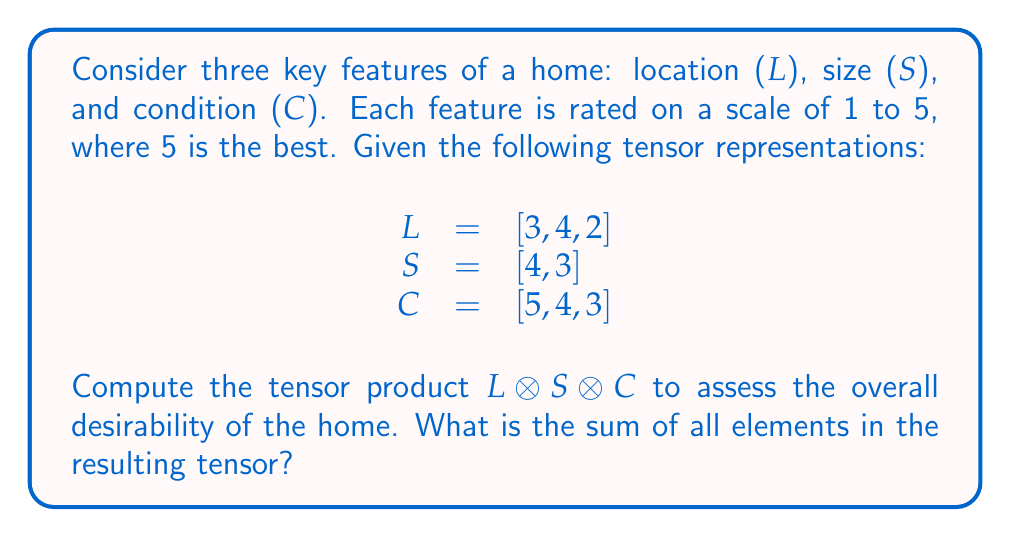What is the answer to this math problem? To solve this problem, we'll follow these steps:

1) First, let's understand what the tensor product means in this context:
   - L represents location factors (e.g., proximity to work, schools, amenities)
   - S represents size factors (e.g., square footage, number of rooms)
   - C represents condition factors (e.g., age, maintenance, updates)

2) The tensor product L ⊗ S ⊗ C will result in a 3D tensor where each element is the product of the corresponding elements from L, S, and C.

3) Let's compute the tensor product:

   $$(L \otimes S \otimes C)_{ijk} = L_i \cdot S_j \cdot C_k$$

   Where i = 1,2,3; j = 1,2; k = 1,2,3

4) Let's calculate each element:

   $$(3 \cdot 4 \cdot 5) = 60, (3 \cdot 4 \cdot 4) = 48, (3 \cdot 4 \cdot 3) = 36$$
   $$(3 \cdot 3 \cdot 5) = 45, (3 \cdot 3 \cdot 4) = 36, (3 \cdot 3 \cdot 3) = 27$$
   $$(4 \cdot 4 \cdot 5) = 80, (4 \cdot 4 \cdot 4) = 64, (4 \cdot 4 \cdot 3) = 48$$
   $$(4 \cdot 3 \cdot 5) = 60, (4 \cdot 3 \cdot 4) = 48, (4 \cdot 3 \cdot 3) = 36$$
   $$(2 \cdot 4 \cdot 5) = 40, (2 \cdot 4 \cdot 4) = 32, (2 \cdot 4 \cdot 3) = 24$$
   $$(2 \cdot 3 \cdot 5) = 30, (2 \cdot 3 \cdot 4) = 24, (2 \cdot 3 \cdot 3) = 18$$

5) Now, we need to sum all these elements:

   $$60 + 48 + 36 + 45 + 36 + 27 + 80 + 64 + 48 + 60 + 48 + 36 + 40 + 32 + 24 + 30 + 24 + 18 = 756$$

The sum of all elements in the resulting tensor is 756.
Answer: 756 